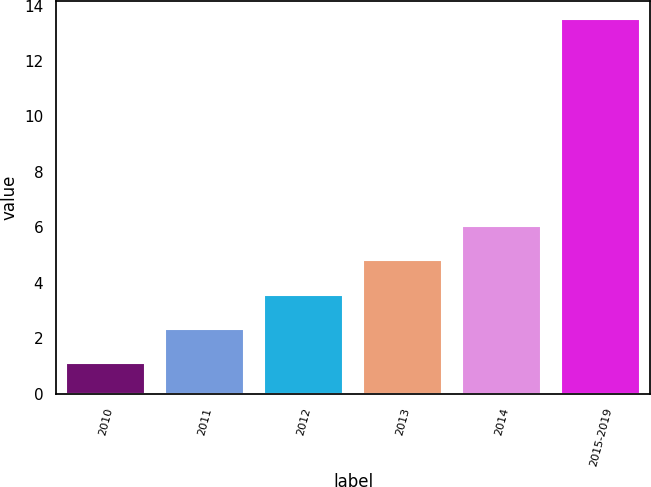Convert chart to OTSL. <chart><loc_0><loc_0><loc_500><loc_500><bar_chart><fcel>2010<fcel>2011<fcel>2012<fcel>2013<fcel>2014<fcel>2015-2019<nl><fcel>1.1<fcel>2.34<fcel>3.58<fcel>4.82<fcel>6.06<fcel>13.5<nl></chart> 